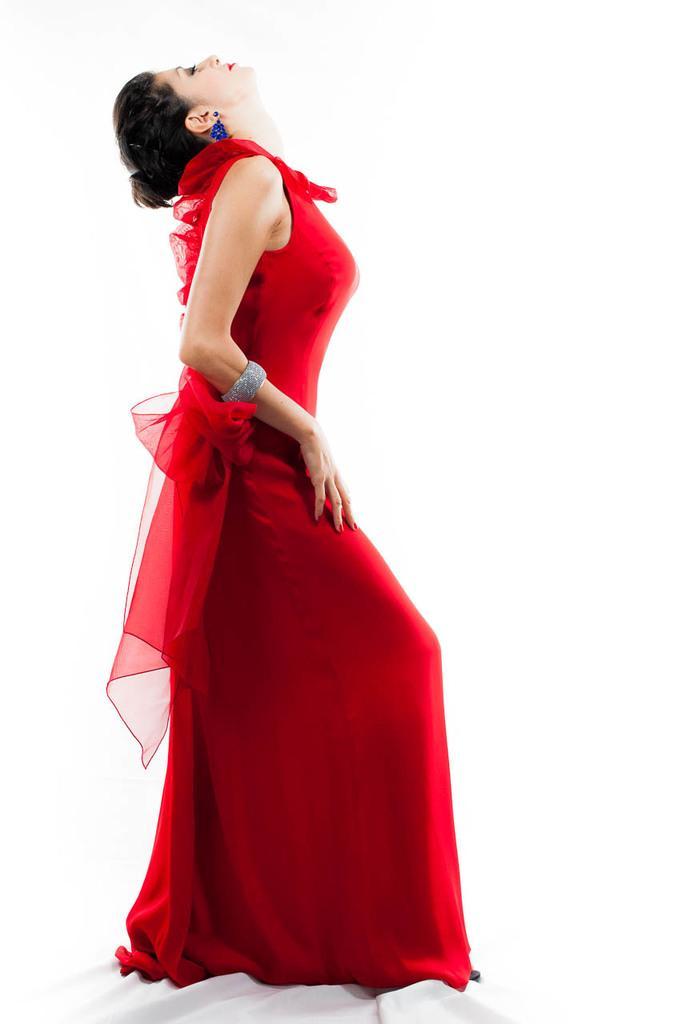In one or two sentences, can you explain what this image depicts? In this image there is a lady wearing red color dress, in the background it is white. 